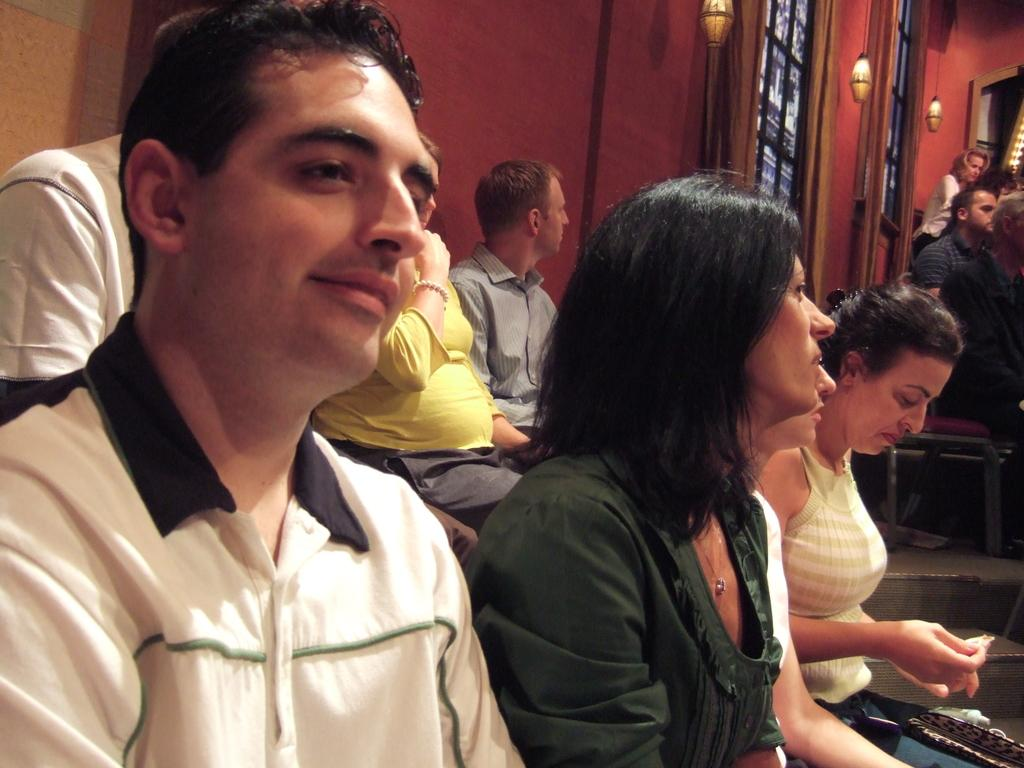What is happening in the room in the image? There are people sitting in the room. What can be seen hanging from the roof in the image? There are lights hanging from the roof. What allows natural light to enter the room? There are windows in the room. What type of animals can be seen in the zoo in the image? There is no zoo present in the image; it features a room with people sitting in it. What type of camera is being used to take the picture in the image? There is no camera visible in the image, as it is not a photograph of someone taking a picture. 